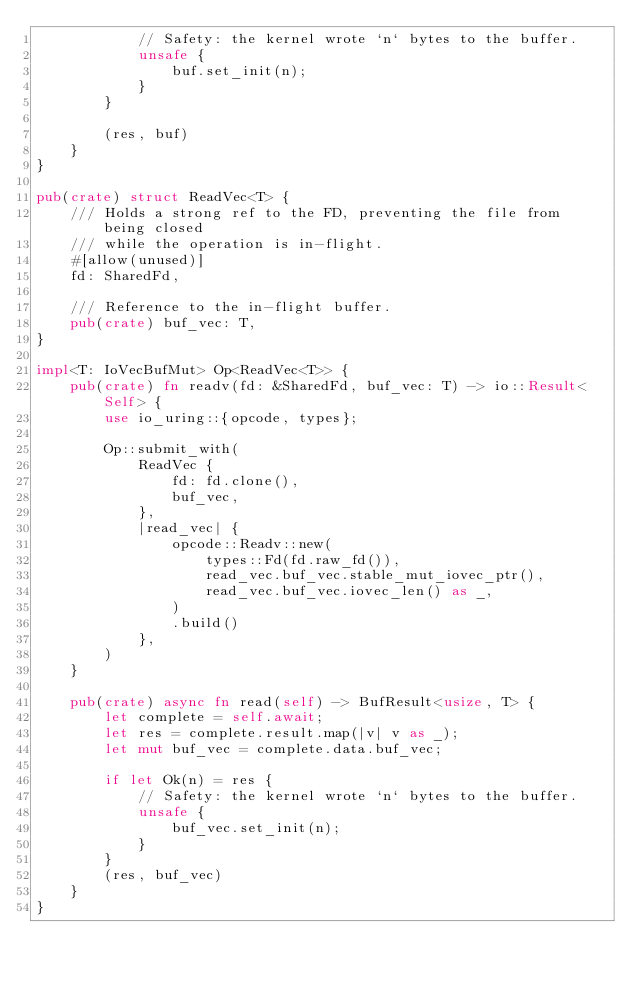<code> <loc_0><loc_0><loc_500><loc_500><_Rust_>            // Safety: the kernel wrote `n` bytes to the buffer.
            unsafe {
                buf.set_init(n);
            }
        }

        (res, buf)
    }
}

pub(crate) struct ReadVec<T> {
    /// Holds a strong ref to the FD, preventing the file from being closed
    /// while the operation is in-flight.
    #[allow(unused)]
    fd: SharedFd,

    /// Reference to the in-flight buffer.
    pub(crate) buf_vec: T,
}

impl<T: IoVecBufMut> Op<ReadVec<T>> {
    pub(crate) fn readv(fd: &SharedFd, buf_vec: T) -> io::Result<Self> {
        use io_uring::{opcode, types};

        Op::submit_with(
            ReadVec {
                fd: fd.clone(),
                buf_vec,
            },
            |read_vec| {
                opcode::Readv::new(
                    types::Fd(fd.raw_fd()),
                    read_vec.buf_vec.stable_mut_iovec_ptr(),
                    read_vec.buf_vec.iovec_len() as _,
                )
                .build()
            },
        )
    }

    pub(crate) async fn read(self) -> BufResult<usize, T> {
        let complete = self.await;
        let res = complete.result.map(|v| v as _);
        let mut buf_vec = complete.data.buf_vec;

        if let Ok(n) = res {
            // Safety: the kernel wrote `n` bytes to the buffer.
            unsafe {
                buf_vec.set_init(n);
            }
        }
        (res, buf_vec)
    }
}
</code> 